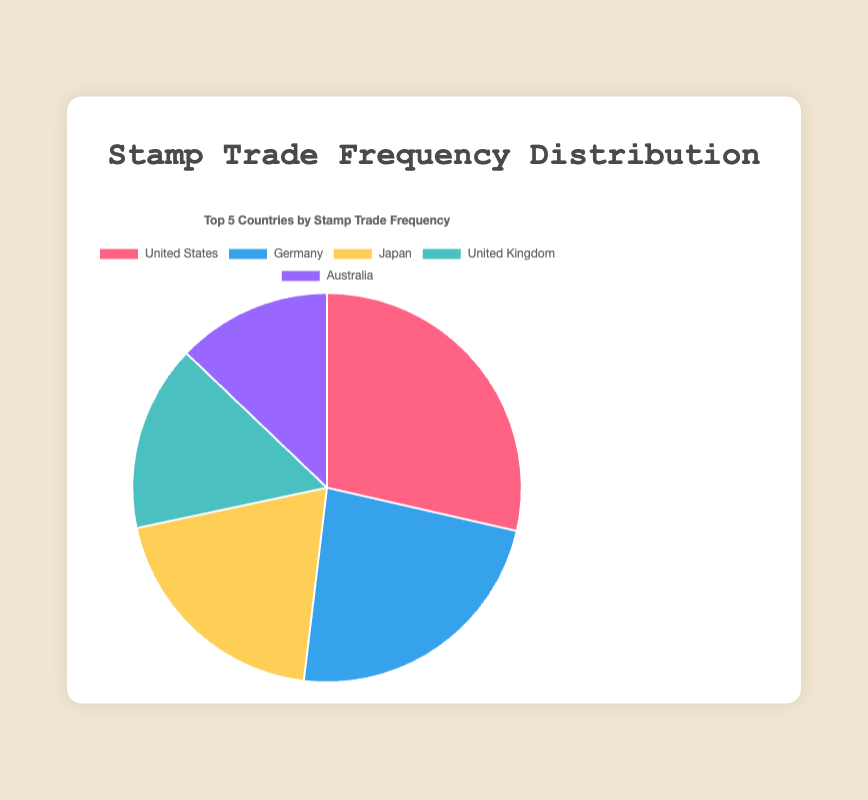Which country had the highest number of stamp trades? The country with the highest number of trades is the country where the largest slice of the pie chart is labeled "United States."
Answer: United States What is the sum of stamp trades for Germany and Japan? The number of stamp trades for Germany is 980, and for Japan is 830. Adding these together gives 980 + 830 = 1810.
Answer: 1810 Which slice represents the third-highest stamp trade frequency? The third-largest slice, in descending order of frequency, is labeled "Japan."
Answer: Japan Is the number of trades in the United Kingdom greater than in Australia? The number of trades in the United Kingdom is 650, while in Australia, it is 540. Since 650 is greater than 540, the answer is yes.
Answer: Yes What is the combined trade frequency for the United Kingdom and Germany? Germany has 980 trades, and the United Kingdom has 650. Adding these gives 980 + 650 = 1630.
Answer: 1630 How many more trades does the United States have than Japan? The United States has 1200 trades and Japan has 830. The difference is 1200 - 830 = 370.
Answer: 370 What percentage of the total trades is contributed by Australia? The total number of trades is 1200 + 980 + 830 + 650 + 540 = 4200. Australia's contribution is (540 / 4200) * 100%, which is approximately 12.86%.
Answer: 12.86% Which country has the smallest slice in the pie chart? The smallest slice of the pie chart is labeled "Australia," indicating it has the smallest trade frequency among the five countries.
Answer: Australia 